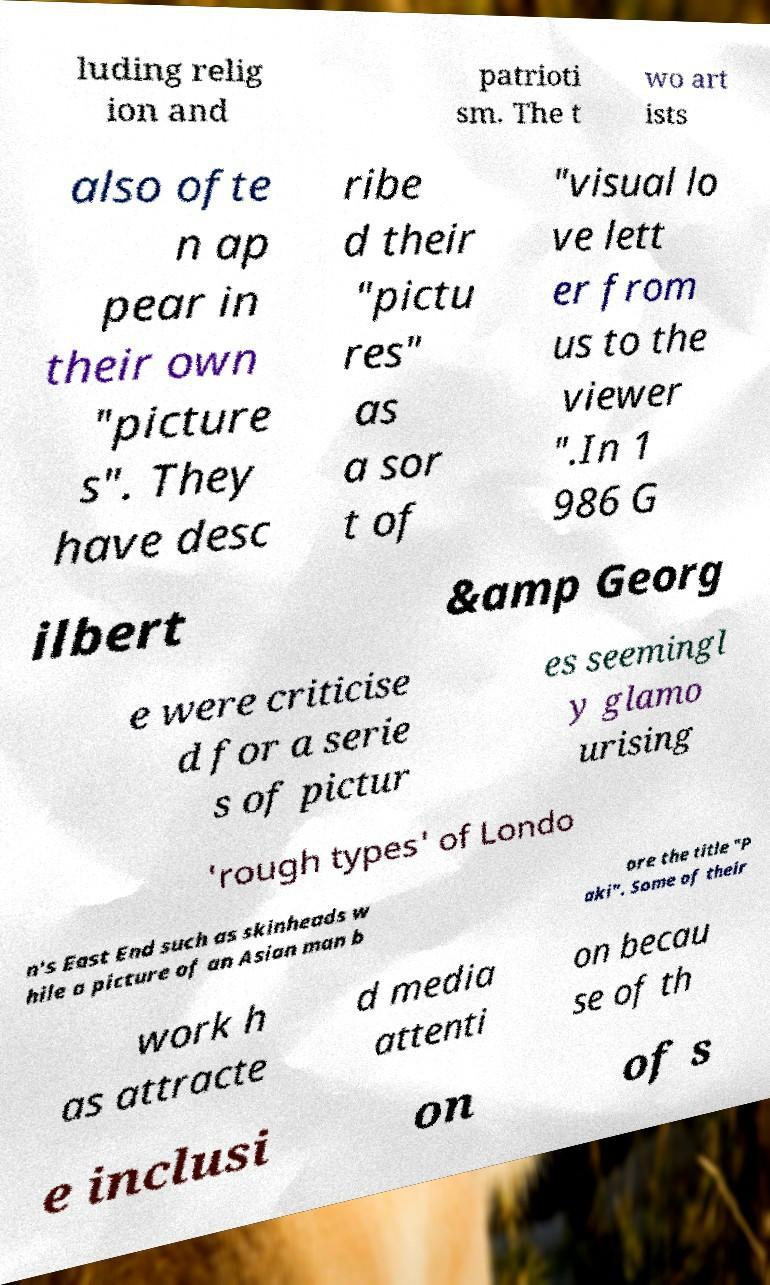Could you extract and type out the text from this image? luding relig ion and patrioti sm. The t wo art ists also ofte n ap pear in their own "picture s". They have desc ribe d their "pictu res" as a sor t of "visual lo ve lett er from us to the viewer ".In 1 986 G ilbert &amp Georg e were criticise d for a serie s of pictur es seemingl y glamo urising 'rough types' of Londo n's East End such as skinheads w hile a picture of an Asian man b ore the title "P aki". Some of their work h as attracte d media attenti on becau se of th e inclusi on of s 